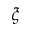Convert formula to latex. <formula><loc_0><loc_0><loc_500><loc_500>\xi</formula> 